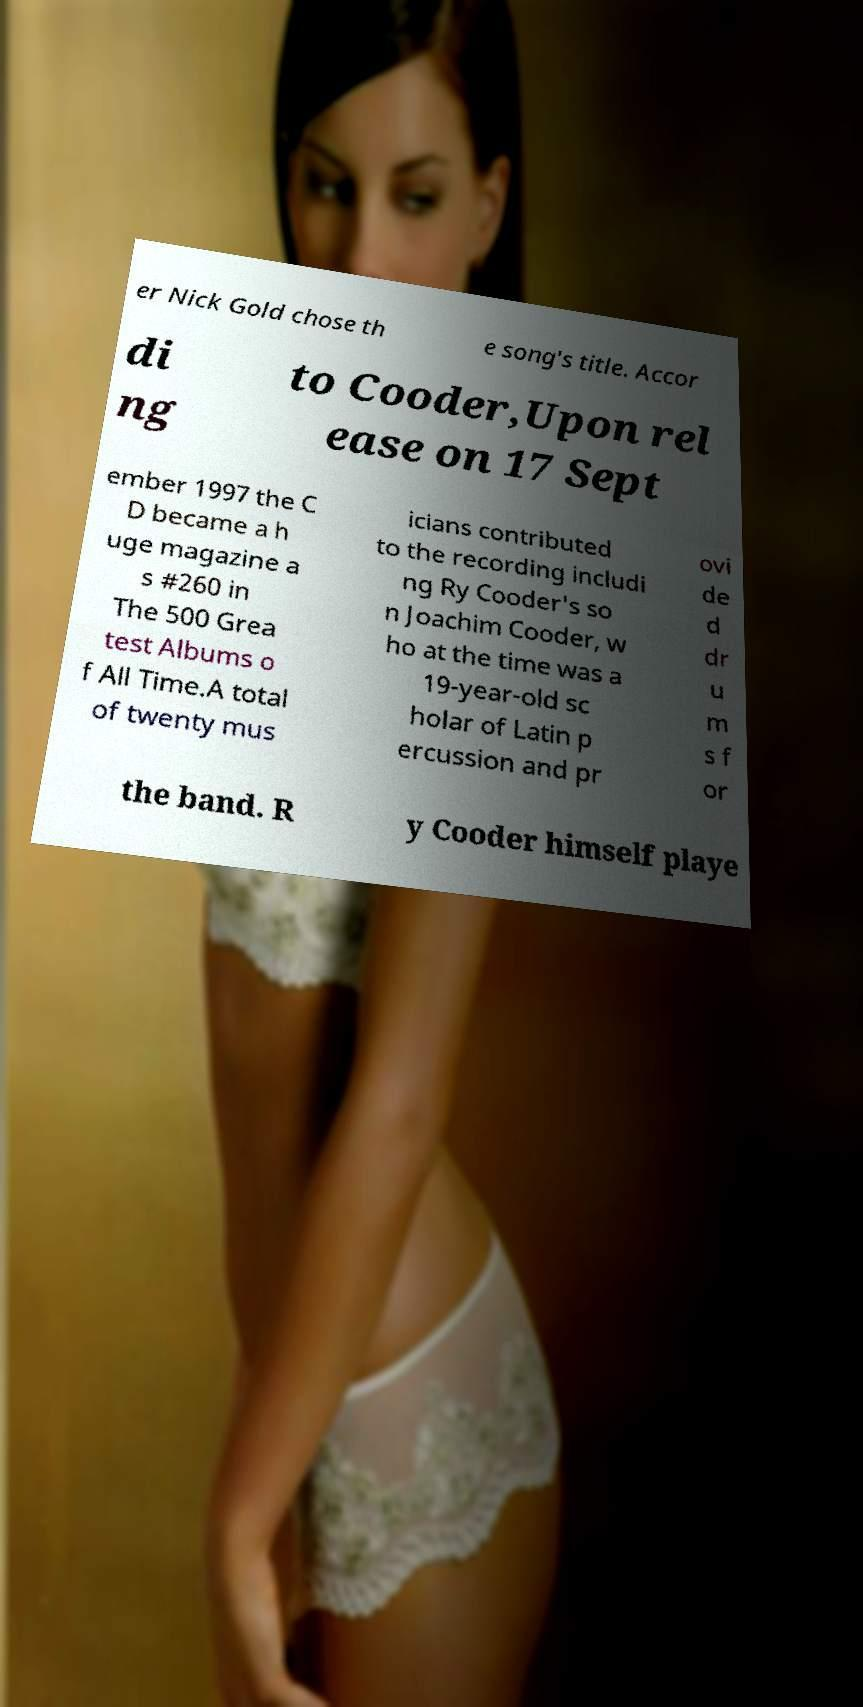Could you extract and type out the text from this image? er Nick Gold chose th e song's title. Accor di ng to Cooder,Upon rel ease on 17 Sept ember 1997 the C D became a h uge magazine a s #260 in The 500 Grea test Albums o f All Time.A total of twenty mus icians contributed to the recording includi ng Ry Cooder's so n Joachim Cooder, w ho at the time was a 19-year-old sc holar of Latin p ercussion and pr ovi de d dr u m s f or the band. R y Cooder himself playe 